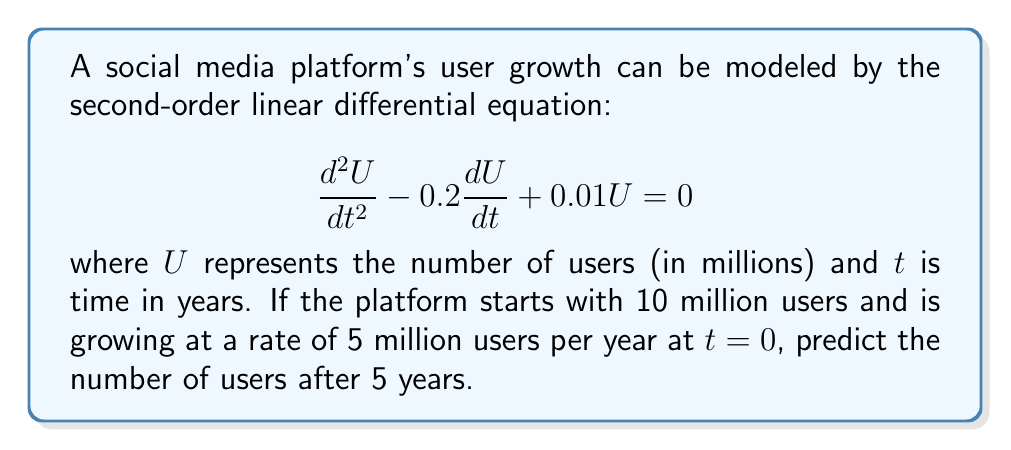Help me with this question. To solve this problem, we need to follow these steps:

1) The general solution for this second-order linear differential equation is:

   $$U(t) = C_1e^{r_1t} + C_2e^{r_2t}$$

   where $r_1$ and $r_2$ are the roots of the characteristic equation:

   $$r^2 - 0.2r + 0.01 = 0$$

2) Solving the characteristic equation:
   
   $$r = \frac{0.2 \pm \sqrt{0.04 - 0.04}}{2} = 0.1$$

   So, $r_1 = r_2 = 0.1$

3) Therefore, the general solution is:

   $$U(t) = (C_1 + C_2t)e^{0.1t}$$

4) We use the initial conditions to find $C_1$ and $C_2$:
   
   At $t=0$, $U(0) = 10$ and $U'(0) = 5$

   $$U(0) = C_1 = 10$$
   $$U'(t) = (0.1C_1 + 0.1C_2t + C_2)e^{0.1t}$$
   $$U'(0) = 0.1C_1 + C_2 = 5$$

5) Substituting $C_1 = 10$ into the second equation:

   $$0.1(10) + C_2 = 5$$
   $$C_2 = 4$$

6) Therefore, the particular solution is:

   $$U(t) = (10 + 4t)e^{0.1t}$$

7) To find the number of users after 5 years, we substitute $t=5$:

   $$U(5) = (10 + 4(5))e^{0.1(5)} = 30e^{0.5} \approx 49.18$$
Answer: After 5 years, the social media platform will have approximately 49.18 million users. 